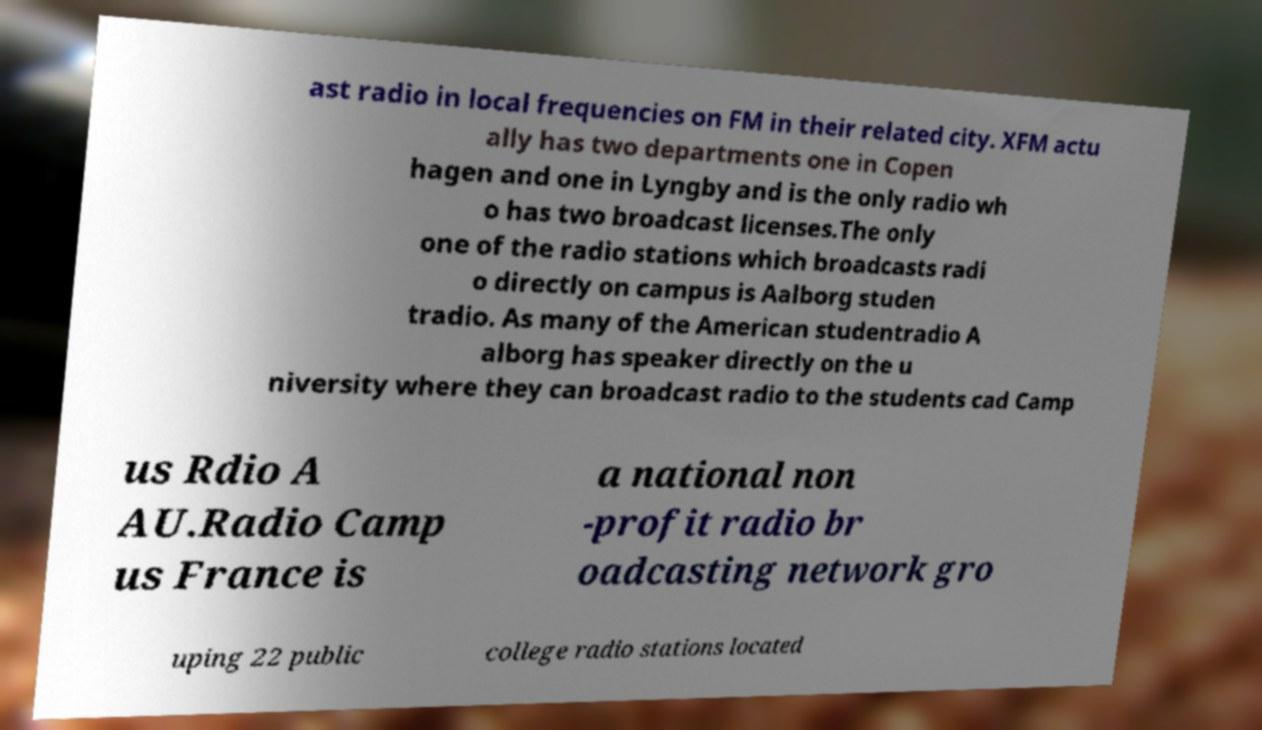Please read and relay the text visible in this image. What does it say? ast radio in local frequencies on FM in their related city. XFM actu ally has two departments one in Copen hagen and one in Lyngby and is the only radio wh o has two broadcast licenses.The only one of the radio stations which broadcasts radi o directly on campus is Aalborg studen tradio. As many of the American studentradio A alborg has speaker directly on the u niversity where they can broadcast radio to the students cad Camp us Rdio A AU.Radio Camp us France is a national non -profit radio br oadcasting network gro uping 22 public college radio stations located 